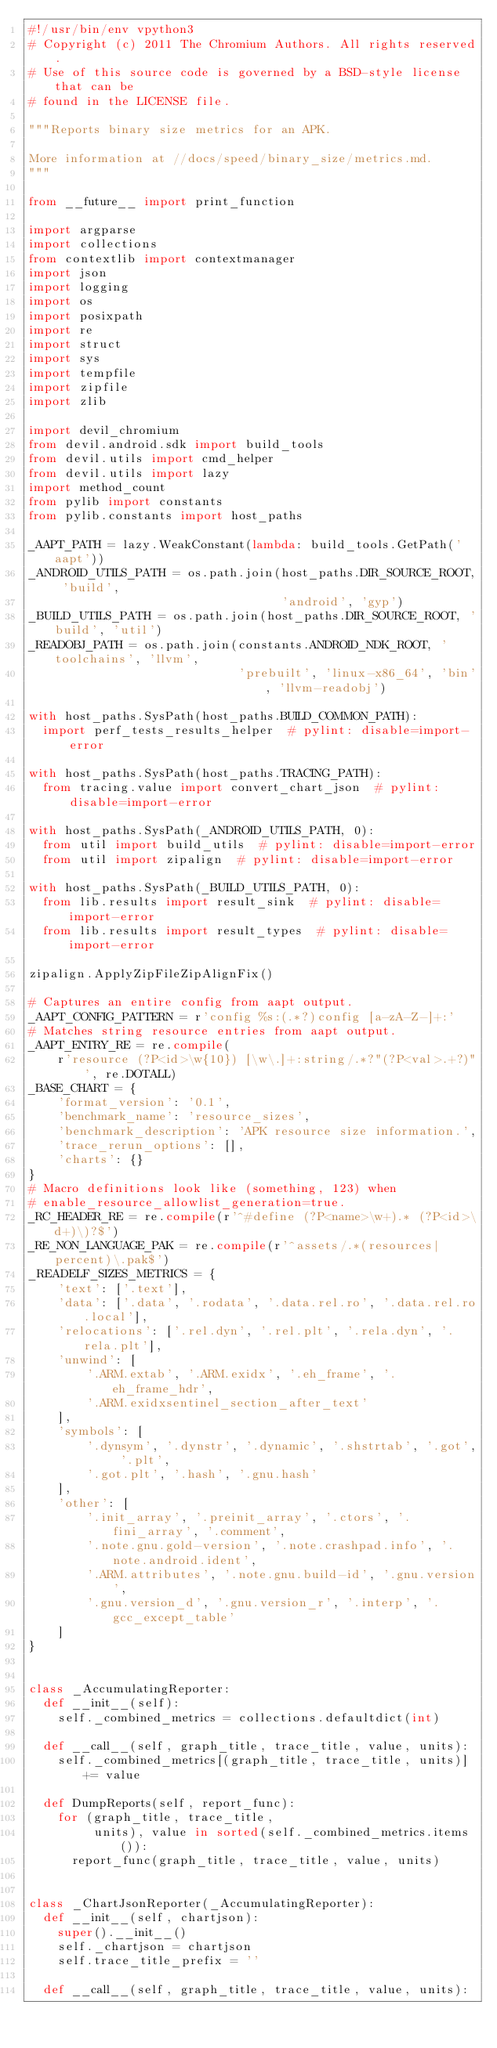<code> <loc_0><loc_0><loc_500><loc_500><_Python_>#!/usr/bin/env vpython3
# Copyright (c) 2011 The Chromium Authors. All rights reserved.
# Use of this source code is governed by a BSD-style license that can be
# found in the LICENSE file.

"""Reports binary size metrics for an APK.

More information at //docs/speed/binary_size/metrics.md.
"""

from __future__ import print_function

import argparse
import collections
from contextlib import contextmanager
import json
import logging
import os
import posixpath
import re
import struct
import sys
import tempfile
import zipfile
import zlib

import devil_chromium
from devil.android.sdk import build_tools
from devil.utils import cmd_helper
from devil.utils import lazy
import method_count
from pylib import constants
from pylib.constants import host_paths

_AAPT_PATH = lazy.WeakConstant(lambda: build_tools.GetPath('aapt'))
_ANDROID_UTILS_PATH = os.path.join(host_paths.DIR_SOURCE_ROOT, 'build',
                                   'android', 'gyp')
_BUILD_UTILS_PATH = os.path.join(host_paths.DIR_SOURCE_ROOT, 'build', 'util')
_READOBJ_PATH = os.path.join(constants.ANDROID_NDK_ROOT, 'toolchains', 'llvm',
                             'prebuilt', 'linux-x86_64', 'bin', 'llvm-readobj')

with host_paths.SysPath(host_paths.BUILD_COMMON_PATH):
  import perf_tests_results_helper  # pylint: disable=import-error

with host_paths.SysPath(host_paths.TRACING_PATH):
  from tracing.value import convert_chart_json  # pylint: disable=import-error

with host_paths.SysPath(_ANDROID_UTILS_PATH, 0):
  from util import build_utils  # pylint: disable=import-error
  from util import zipalign  # pylint: disable=import-error

with host_paths.SysPath(_BUILD_UTILS_PATH, 0):
  from lib.results import result_sink  # pylint: disable=import-error
  from lib.results import result_types  # pylint: disable=import-error

zipalign.ApplyZipFileZipAlignFix()

# Captures an entire config from aapt output.
_AAPT_CONFIG_PATTERN = r'config %s:(.*?)config [a-zA-Z-]+:'
# Matches string resource entries from aapt output.
_AAPT_ENTRY_RE = re.compile(
    r'resource (?P<id>\w{10}) [\w\.]+:string/.*?"(?P<val>.+?)"', re.DOTALL)
_BASE_CHART = {
    'format_version': '0.1',
    'benchmark_name': 'resource_sizes',
    'benchmark_description': 'APK resource size information.',
    'trace_rerun_options': [],
    'charts': {}
}
# Macro definitions look like (something, 123) when
# enable_resource_allowlist_generation=true.
_RC_HEADER_RE = re.compile(r'^#define (?P<name>\w+).* (?P<id>\d+)\)?$')
_RE_NON_LANGUAGE_PAK = re.compile(r'^assets/.*(resources|percent)\.pak$')
_READELF_SIZES_METRICS = {
    'text': ['.text'],
    'data': ['.data', '.rodata', '.data.rel.ro', '.data.rel.ro.local'],
    'relocations': ['.rel.dyn', '.rel.plt', '.rela.dyn', '.rela.plt'],
    'unwind': [
        '.ARM.extab', '.ARM.exidx', '.eh_frame', '.eh_frame_hdr',
        '.ARM.exidxsentinel_section_after_text'
    ],
    'symbols': [
        '.dynsym', '.dynstr', '.dynamic', '.shstrtab', '.got', '.plt',
        '.got.plt', '.hash', '.gnu.hash'
    ],
    'other': [
        '.init_array', '.preinit_array', '.ctors', '.fini_array', '.comment',
        '.note.gnu.gold-version', '.note.crashpad.info', '.note.android.ident',
        '.ARM.attributes', '.note.gnu.build-id', '.gnu.version',
        '.gnu.version_d', '.gnu.version_r', '.interp', '.gcc_except_table'
    ]
}


class _AccumulatingReporter:
  def __init__(self):
    self._combined_metrics = collections.defaultdict(int)

  def __call__(self, graph_title, trace_title, value, units):
    self._combined_metrics[(graph_title, trace_title, units)] += value

  def DumpReports(self, report_func):
    for (graph_title, trace_title,
         units), value in sorted(self._combined_metrics.items()):
      report_func(graph_title, trace_title, value, units)


class _ChartJsonReporter(_AccumulatingReporter):
  def __init__(self, chartjson):
    super().__init__()
    self._chartjson = chartjson
    self.trace_title_prefix = ''

  def __call__(self, graph_title, trace_title, value, units):</code> 